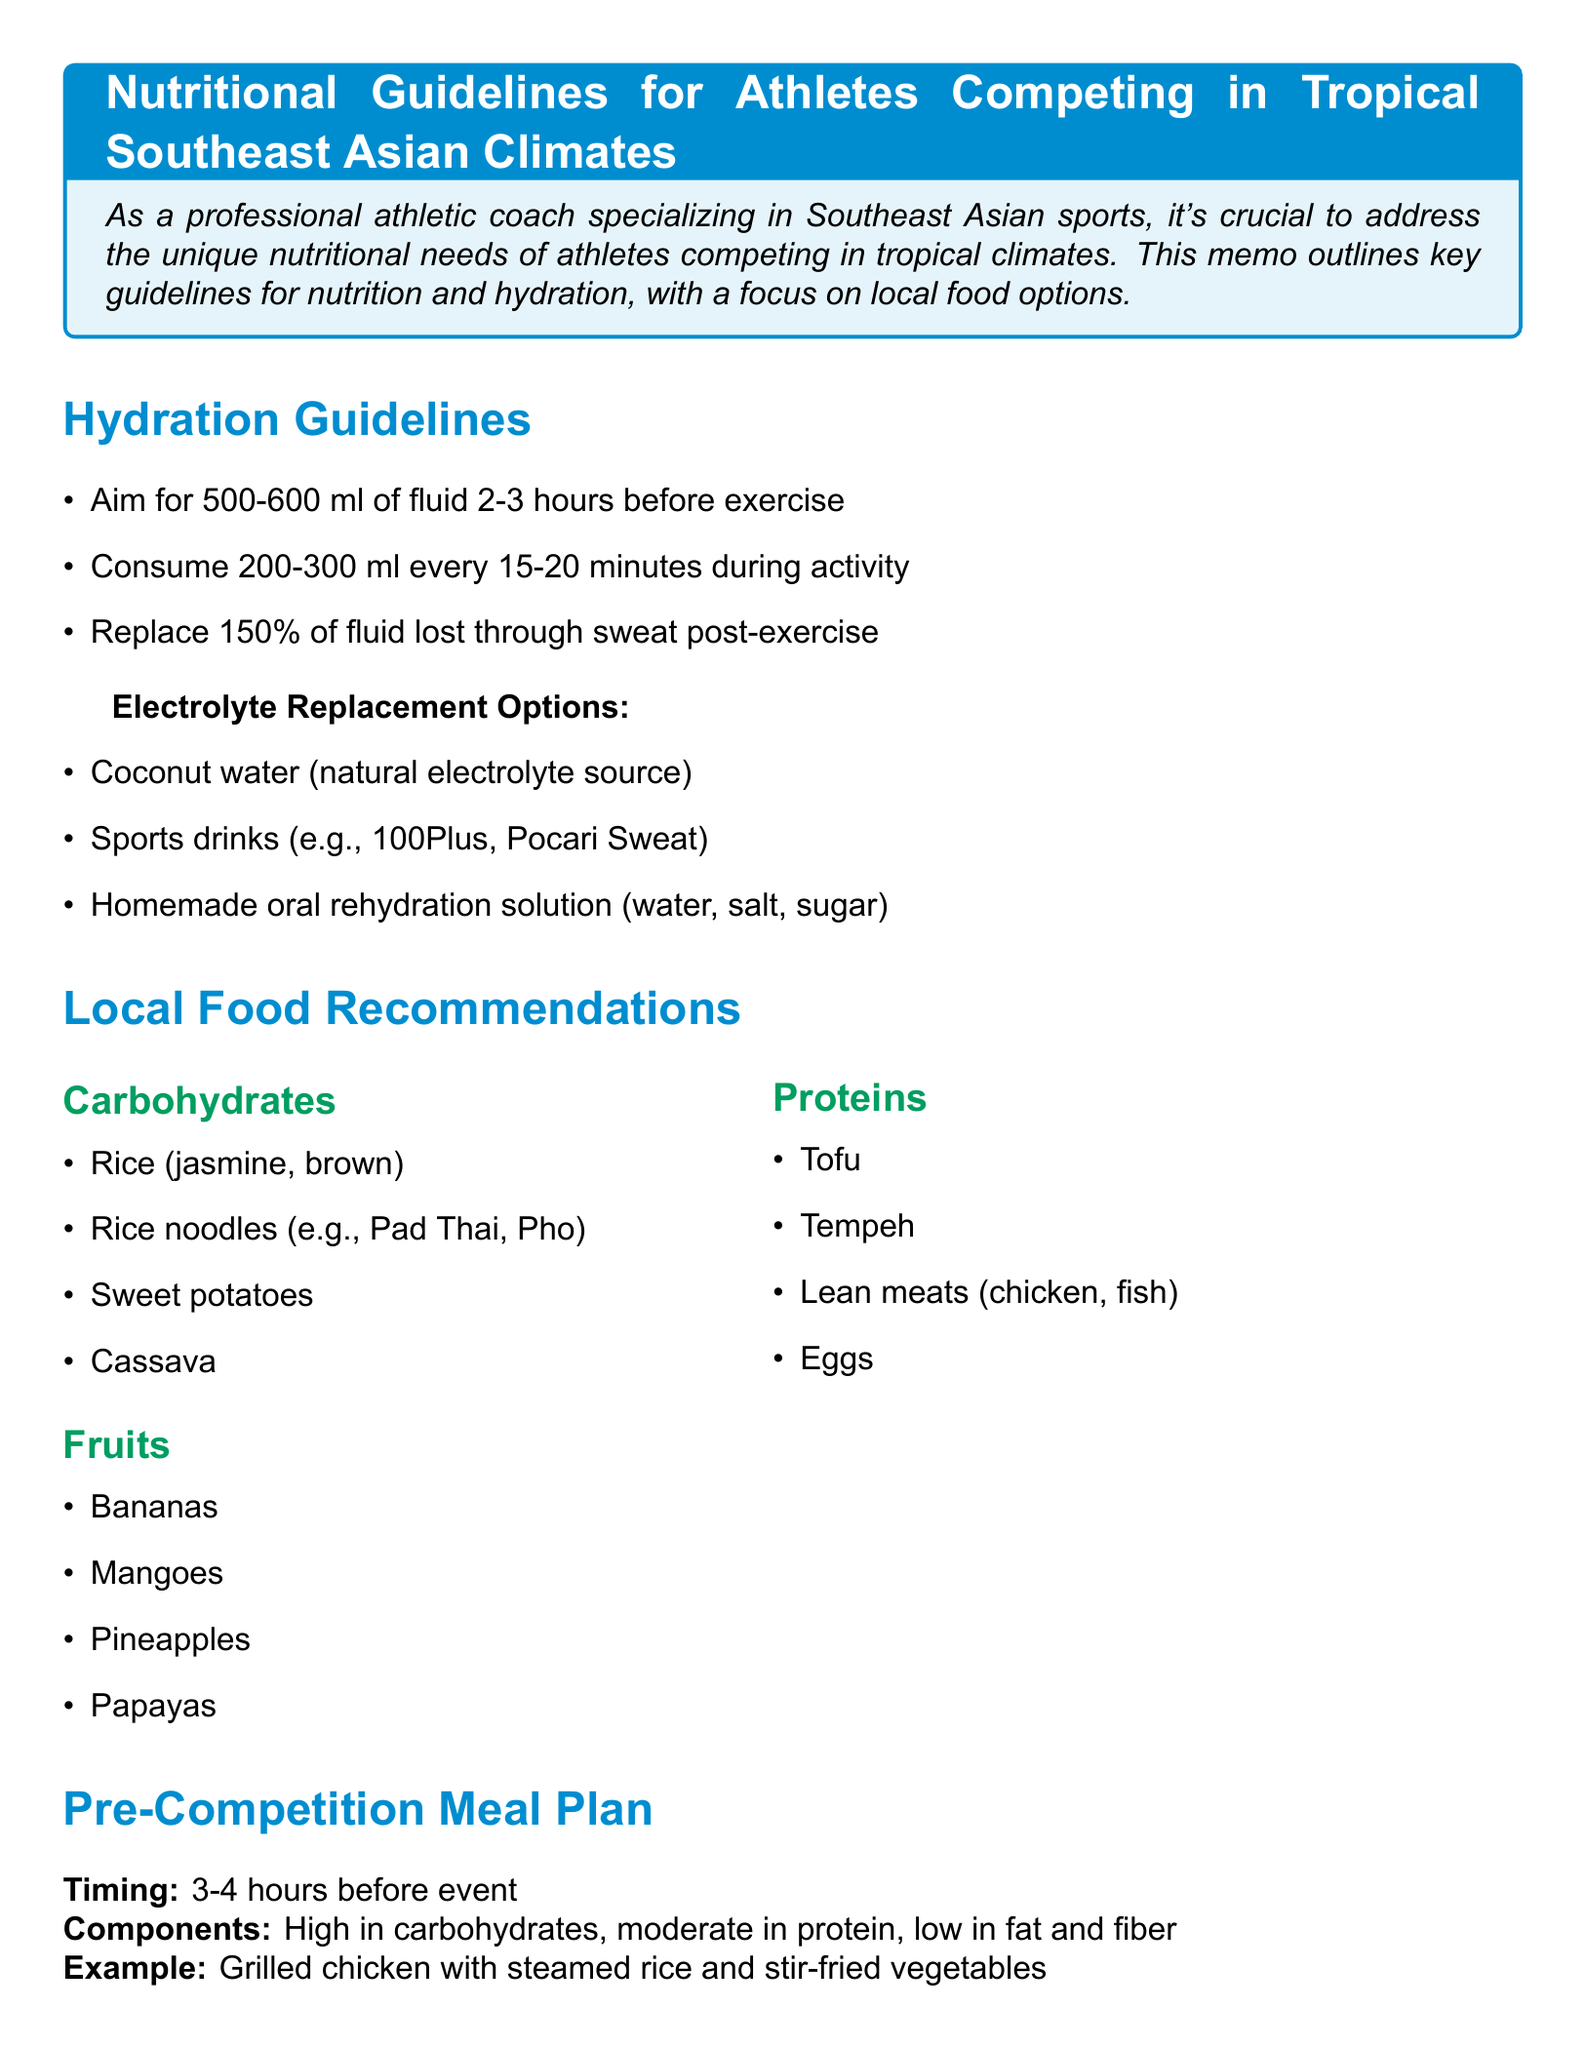What is the title of the memo? The title is stated at the very beginning of the document.
Answer: Nutritional Guidelines for Athletes Competing in Tropical Southeast Asian Climates How much fluid should an athlete consume 2-3 hours before exercise? This information is mentioned under Hydration Strategies in the document.
Answer: 500-600 ml What is a recommended source of electrolytes? This information is found in the section about Electrolyte Replacement Options.
Answer: Coconut water When should the pre-competition meal be consumed? The timing for the pre-competition meal is clearly stated in the Pre-Competition Meal Plan section.
Answer: 3-4 hours before event What is an example of a recovery nutrition option? An example is provided in the Recovery Nutrition section of the document.
Answer: Milo with low-fat milk and a banana What should the carbohydrate intake be post-exercise? The document specifies the amount required as part of the recovery nutrition.
Answer: 1g per kg body weight Why is it suggested to avoid heavy, spicy foods before competition? This is mentioned as part of Additional Tips, emphasizing impact on performance.
Answer: To prevent digestive issues What local fruit is recommended for athletes? This is found in the Local Food Recommendations section under Fruits.
Answer: Bananas 